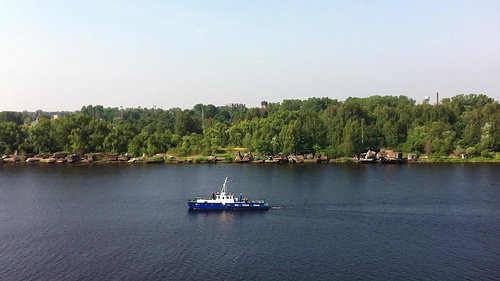Please provide the bounding box coordinate of the region this sentence describes: shore line covered with trees. Shore line covered with dense, lush green foliage extends from coordinates [0.01, 0.42, 1.0, 0.56], creating a natural barrier along the river. 